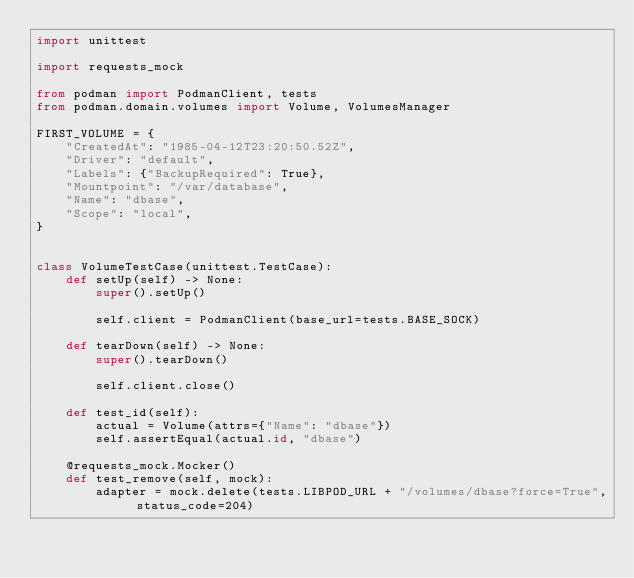<code> <loc_0><loc_0><loc_500><loc_500><_Python_>import unittest

import requests_mock

from podman import PodmanClient, tests
from podman.domain.volumes import Volume, VolumesManager

FIRST_VOLUME = {
    "CreatedAt": "1985-04-12T23:20:50.52Z",
    "Driver": "default",
    "Labels": {"BackupRequired": True},
    "Mountpoint": "/var/database",
    "Name": "dbase",
    "Scope": "local",
}


class VolumeTestCase(unittest.TestCase):
    def setUp(self) -> None:
        super().setUp()

        self.client = PodmanClient(base_url=tests.BASE_SOCK)

    def tearDown(self) -> None:
        super().tearDown()

        self.client.close()

    def test_id(self):
        actual = Volume(attrs={"Name": "dbase"})
        self.assertEqual(actual.id, "dbase")

    @requests_mock.Mocker()
    def test_remove(self, mock):
        adapter = mock.delete(tests.LIBPOD_URL + "/volumes/dbase?force=True", status_code=204)</code> 